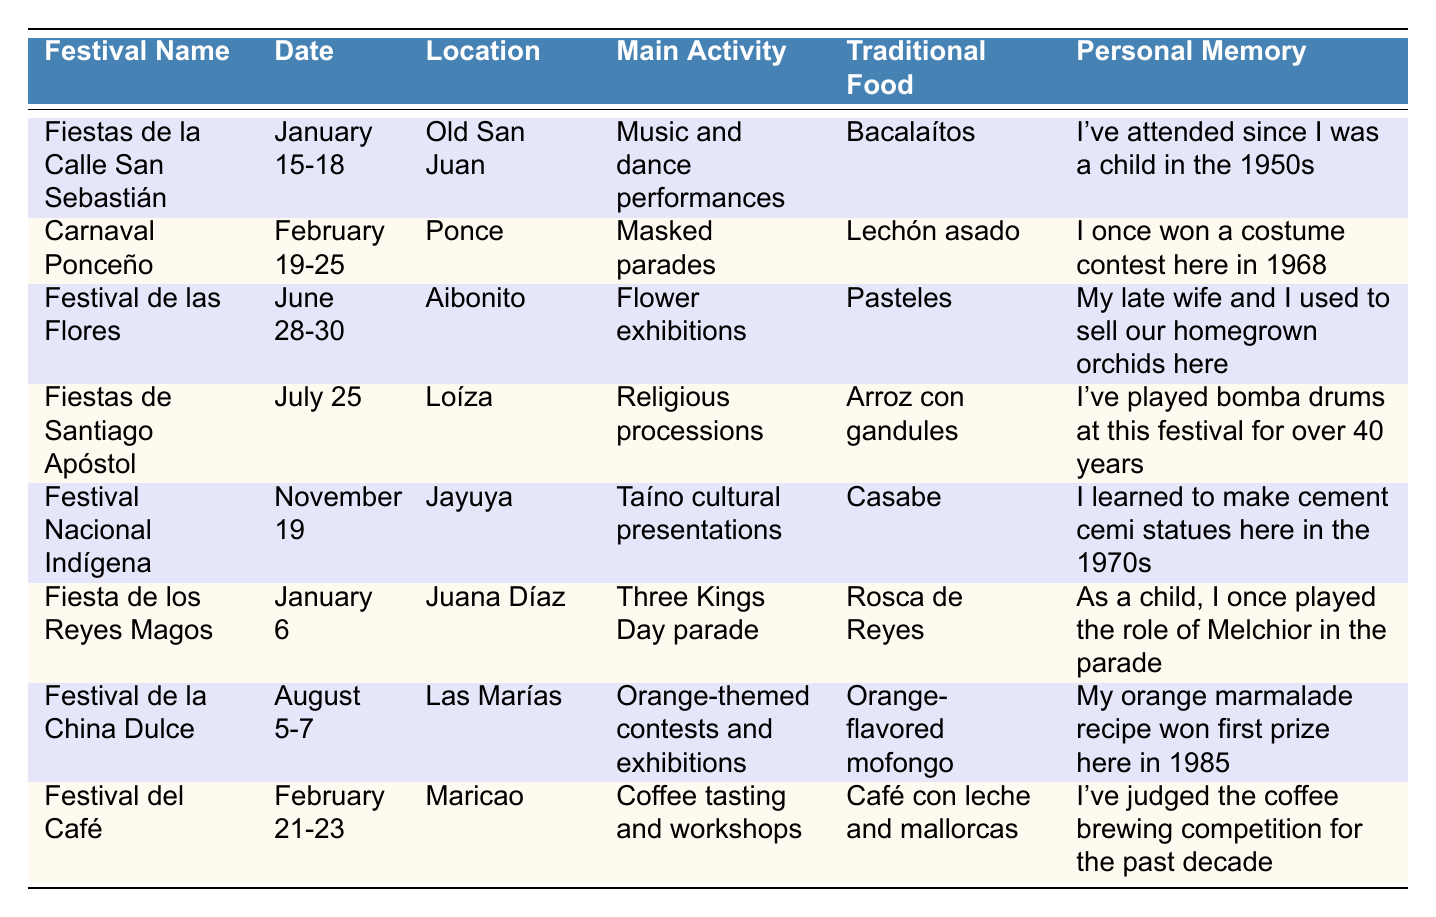What is the date of the Fiestas de la Calle San Sebastián? The date is listed directly in the table under the "Date" column for the festival named "Fiestas de la Calle San Sebastián". Referring to the table, it states the date as "January 15-18".
Answer: January 15-18 Which festival takes place in February and features mask parades? The table lists festivals along with their corresponding months. Searching through the festivals in February, "Carnaval Ponceño" is marked with the main activity as "Masked parades".
Answer: Carnaval Ponceño How many days does the Festival de la China Dulce last? The duration of the festival can be found in the "Date" column. "Festival de la China Dulce" has the date listed as "August 5-7", indicating it lasts for three days.
Answer: 3 days What traditional food is served during the Fiestas de Santiago Apóstol? The "Traditional Food" column provides the specific food for each festival. For the Fiestas de Santiago Apóstol, it lists "Arroz con gandules".
Answer: Arroz con gandules True or False: The Festival Nacional Indígena happens in the summer. The Festival Nacional Indígena is listed under "November 19", which is during the fall season, not summer. Thus, the statement is false.
Answer: False Which festival has the longest history for the personal memories shared? Analyzing the personal memory associated with each festival, the "Fiestas de la Calle San Sebastián" mentions attendance since the 1950s, indicating a long tradition. Other festivals have less historical depth in the memories shared.
Answer: Fiestas de la Calle San Sebastián What is the primary activity during the Festival de las Flores? The main activity for each festival is found under the "Main Activity" column. For the Festival de las Flores, it is "Flower exhibitions".
Answer: Flower exhibitions Which festival involves coffee tasting and workshops? By checking the festival activities listed in the "Main Activity" column, the "Festival del Café" clearly includes "Coffee tasting and workshops".
Answer: Festival del Café Count how many festivals occur in January. The table shows two festivals in January: "Fiestas de la Calle San Sebastián" (January 15-18) and "Fiesta de los Reyes Magos" (January 6). Therefore, the total number is 2.
Answer: 2 What festival would you attend if you wanted to see Taíno culture presented? The table specifies "Taíno cultural presentations" under the main activity for "Festival Nacional Indígena" which takes place on November 19.
Answer: Festival Nacional Indígena 